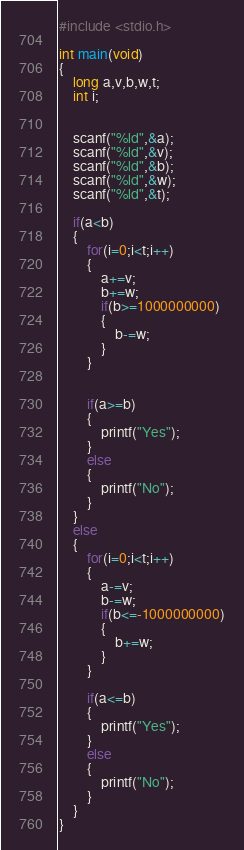<code> <loc_0><loc_0><loc_500><loc_500><_C_>#include <stdio.h>

int main(void)
{
	long a,v,b,w,t;
	int i;
	
	
	scanf("%ld",&a);
	scanf("%ld",&v);
	scanf("%ld",&b);
	scanf("%ld",&w);
	scanf("%ld",&t);
		
	if(a<b)
	{
		for(i=0;i<t;i++)
		{
			a+=v;
			b+=w;
			if(b>=1000000000)
			{
				b-=w;
			}
		}
		
		
		if(a>=b)
		{
			printf("Yes");
		}
		else
		{
			printf("No");
		}
	}
	else
	{
		for(i=0;i<t;i++)
		{
			a-=v;
			b-=w;
			if(b<=-1000000000)
			{
				b+=w;
			}
		}
		
		if(a<=b)
		{
			printf("Yes");
		}
		else
		{
			printf("No");
		}
	}	
}</code> 